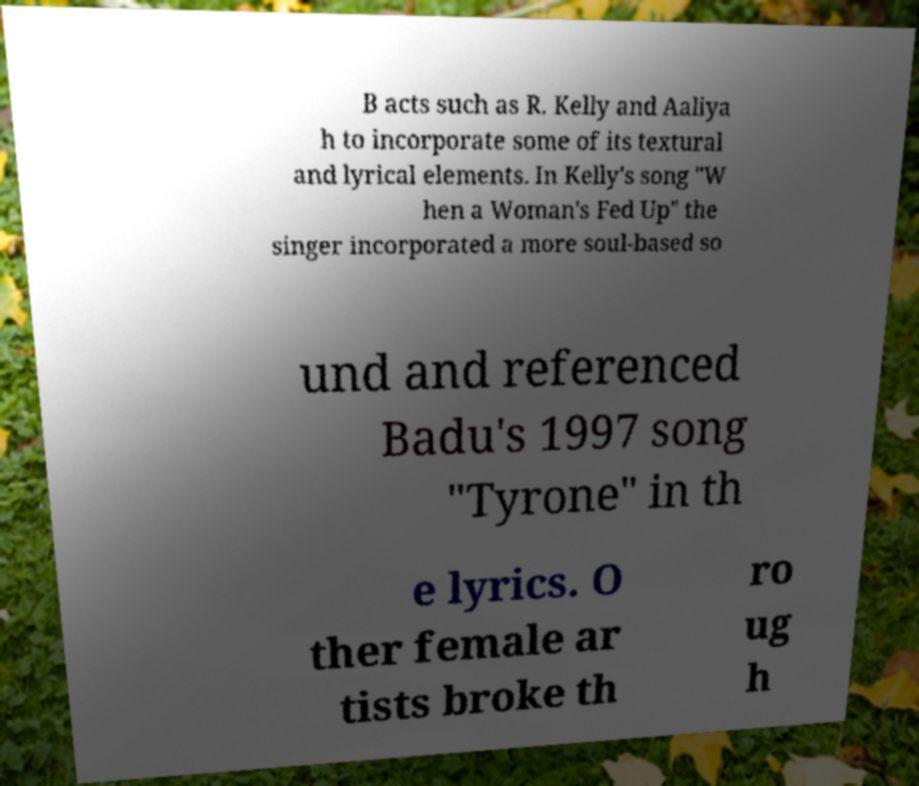For documentation purposes, I need the text within this image transcribed. Could you provide that? B acts such as R. Kelly and Aaliya h to incorporate some of its textural and lyrical elements. In Kelly's song "W hen a Woman's Fed Up" the singer incorporated a more soul-based so und and referenced Badu's 1997 song "Tyrone" in th e lyrics. O ther female ar tists broke th ro ug h 